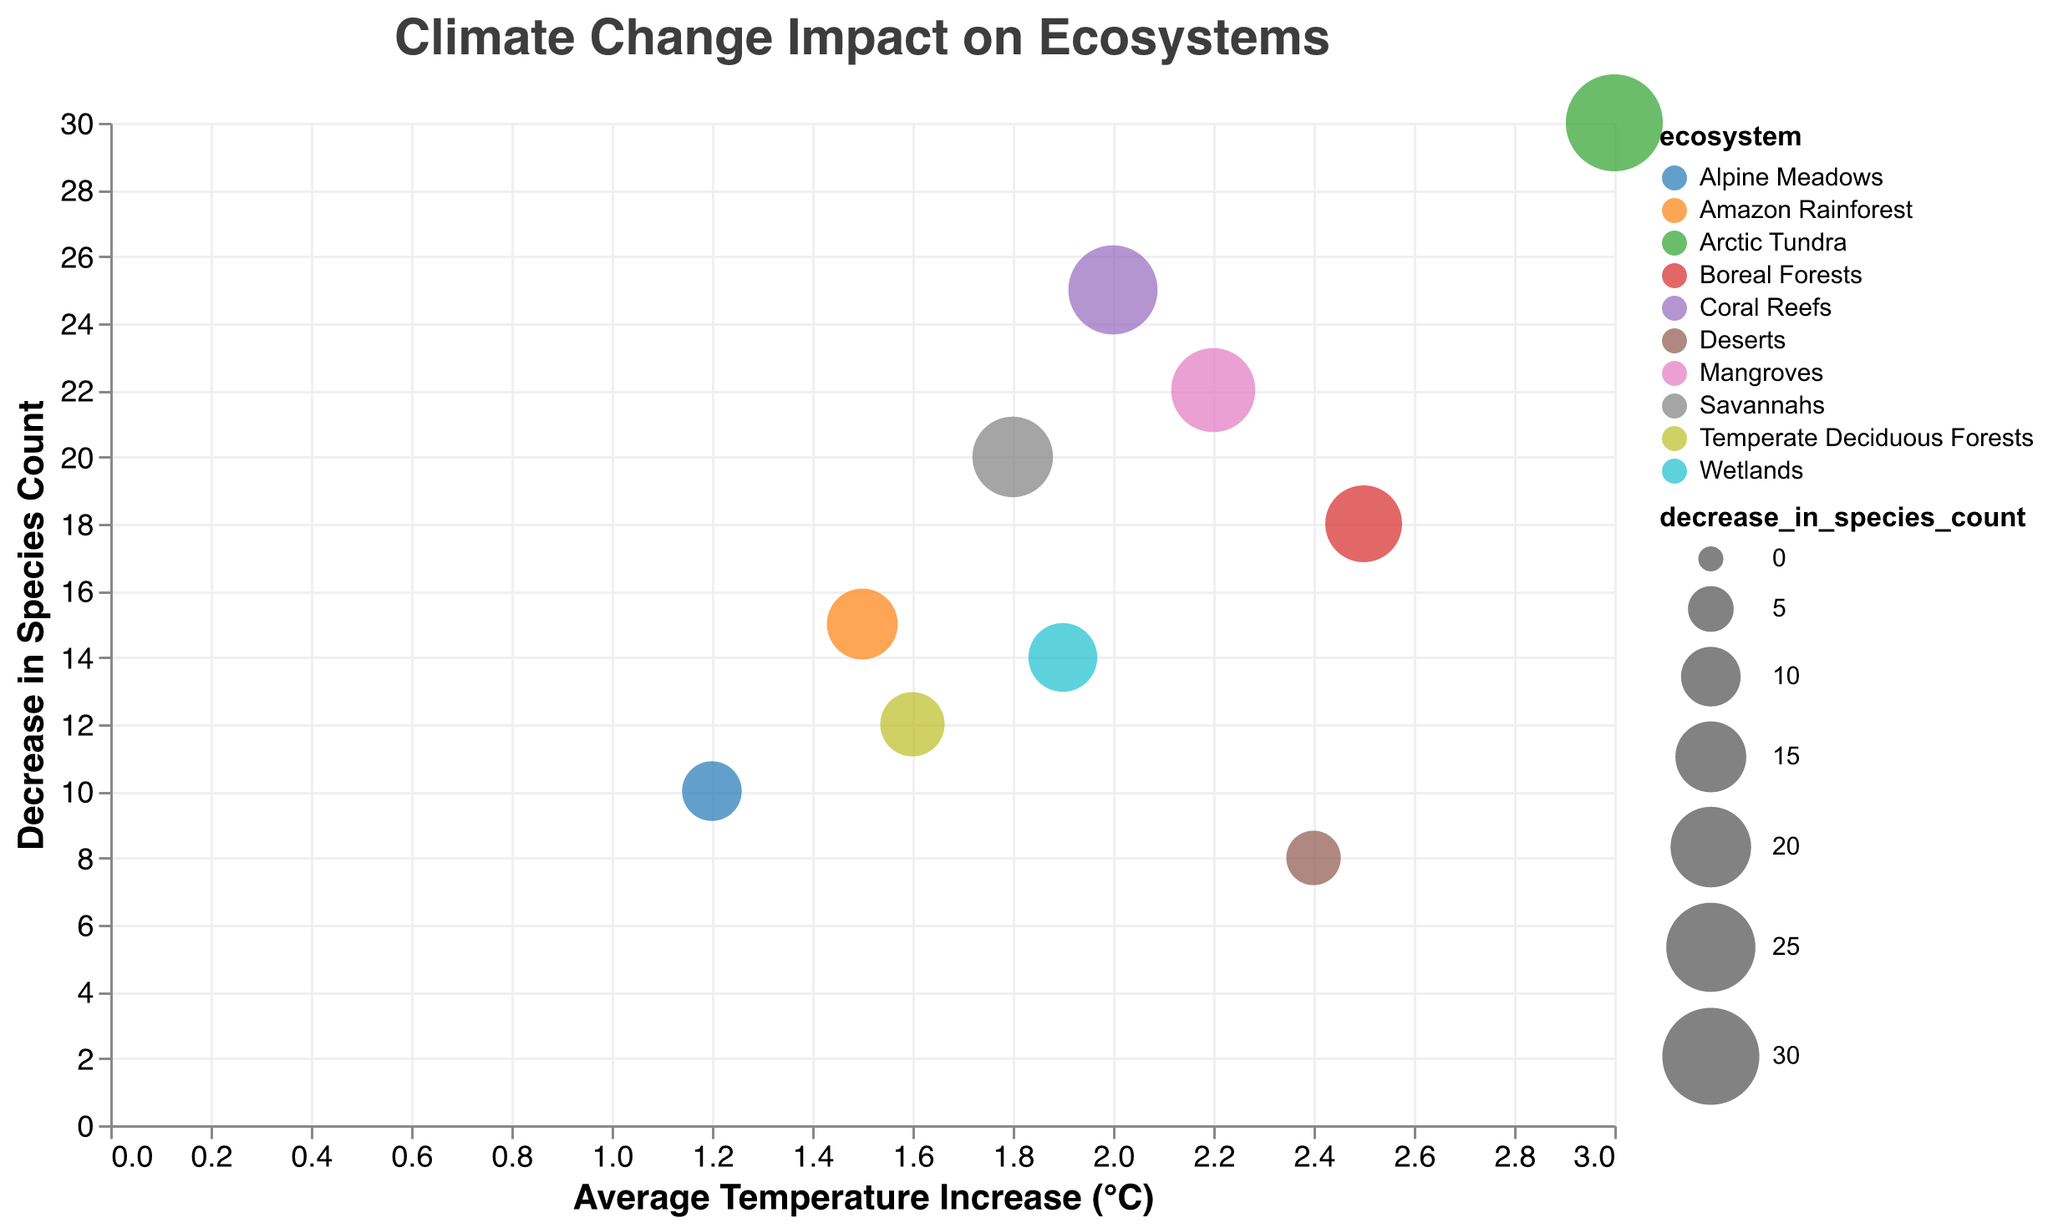What is the title of the figure? The title is usually located at the top of the visual and provides a summary of what the graph is about. In this case, it is "Climate Change Impact on Ecosystems."
Answer: Climate Change Impact on Ecosystems What are the labels on the x-axis and y-axis? The x-axis label typically indicates the independent variable, and the y-axis label indicates the dependent variable. Here, the x-axis is labeled "Average Temperature Increase (°C)" and the y-axis is labeled "Decrease in Species Count."
Answer: Average Temperature Increase (°C) and Decrease in Species Count Which ecosystem has the highest average temperature increase? To find this, look for the bubble farthest to the right in the plot, which represents the highest value on the x-axis. The "Arctic Tundra" is associated with the highest average temperature increase of 3.0°C.
Answer: Arctic Tundra How many ecosystems are represented in the figure? Each bubble in the chart represents one ecosystem. By counting the unique bubbles, we can determine the number of ecosystems represented. There are 10 ecosystems displayed in the bubble chart.
Answer: 10 Which ecosystem experiences a decrease of exactly 22 species due to climate change? Look for the bubble with its size representing 22 on the y-axis, and refer to the tooltip information to confirm the ecosystem. The "Mangroves" ecosystem shows a decrease in species count of 22.
Answer: Mangroves What is the combined decrease in species count for Coral Reefs and Arctic Tundra? The species count decrease for Coral Reefs is 25, and for Arctic Tundra, it is 30. Adding these gives 25 + 30 = 55.
Answer: 55 Which ecosystem has a lower average temperature increase, Alpine Meadows or Savannahs? Compare the positions of the respective bubbles on the x-axis. Alpine Meadows has an average temperature increase of 1.2°C, while Savannahs have 1.8°C. Therefore, Alpine Meadows has a lower average temperature increase.
Answer: Alpine Meadows What is the range of the average temperature increase represented in the plot? Identify the minimum and maximum values on the x-axis. The lowest average temperature increase is 1.2°C (Alpine Meadows), and the highest is 3.0°C (Arctic Tundra). The range is 3.0 - 1.2 = 1.8°C.
Answer: 1.8°C Which ecosystem shows the smallest decrease in species count? Find the smallest bubble, and the tooltip will provide the specific value. The Desert ecosystem shows the smallest decrease in species count, which is 8.
Answer: Deserts Is there a general correlation between average temperature increase and species count decrease? Examine the overall trend of the bubbles. Generally, as the average temperature increase rises, the decrease in species count also increases, indicating a positive correlation.
Answer: Yes 